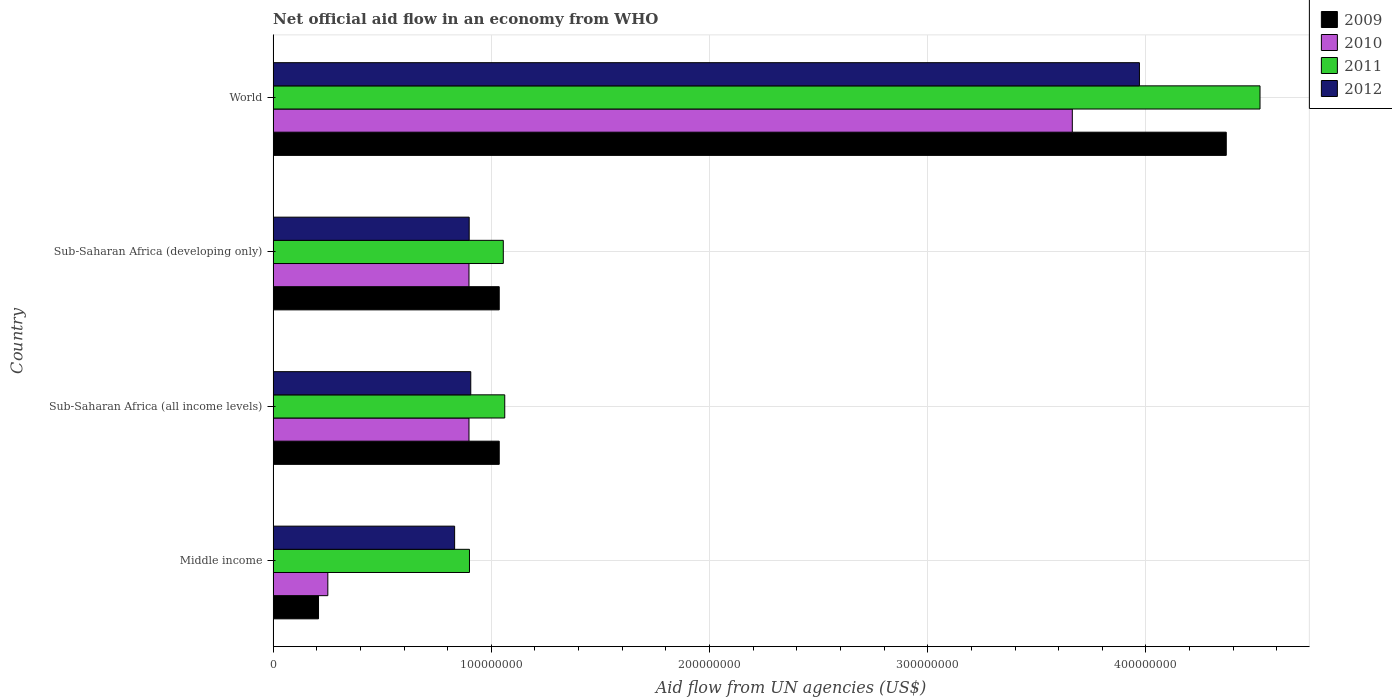How many different coloured bars are there?
Give a very brief answer. 4. Are the number of bars on each tick of the Y-axis equal?
Provide a succinct answer. Yes. How many bars are there on the 1st tick from the top?
Ensure brevity in your answer.  4. What is the label of the 1st group of bars from the top?
Your answer should be compact. World. What is the net official aid flow in 2012 in Sub-Saharan Africa (developing only)?
Keep it short and to the point. 8.98e+07. Across all countries, what is the maximum net official aid flow in 2012?
Offer a terse response. 3.97e+08. Across all countries, what is the minimum net official aid flow in 2011?
Your response must be concise. 9.00e+07. In which country was the net official aid flow in 2011 minimum?
Ensure brevity in your answer.  Middle income. What is the total net official aid flow in 2010 in the graph?
Provide a succinct answer. 5.71e+08. What is the difference between the net official aid flow in 2009 in Sub-Saharan Africa (all income levels) and that in Sub-Saharan Africa (developing only)?
Your answer should be very brief. 0. What is the difference between the net official aid flow in 2011 in Sub-Saharan Africa (all income levels) and the net official aid flow in 2012 in Middle income?
Keep it short and to the point. 2.30e+07. What is the average net official aid flow in 2009 per country?
Your answer should be compact. 1.66e+08. What is the difference between the net official aid flow in 2009 and net official aid flow in 2011 in World?
Your answer should be very brief. -1.55e+07. Is the net official aid flow in 2011 in Middle income less than that in Sub-Saharan Africa (developing only)?
Your answer should be very brief. Yes. Is the difference between the net official aid flow in 2009 in Sub-Saharan Africa (all income levels) and Sub-Saharan Africa (developing only) greater than the difference between the net official aid flow in 2011 in Sub-Saharan Africa (all income levels) and Sub-Saharan Africa (developing only)?
Your response must be concise. No. What is the difference between the highest and the second highest net official aid flow in 2012?
Keep it short and to the point. 3.06e+08. What is the difference between the highest and the lowest net official aid flow in 2011?
Your answer should be compact. 3.62e+08. Is the sum of the net official aid flow in 2009 in Sub-Saharan Africa (developing only) and World greater than the maximum net official aid flow in 2012 across all countries?
Your answer should be very brief. Yes. Is it the case that in every country, the sum of the net official aid flow in 2011 and net official aid flow in 2009 is greater than the sum of net official aid flow in 2012 and net official aid flow in 2010?
Offer a terse response. No. What does the 3rd bar from the top in Middle income represents?
Your answer should be very brief. 2010. Is it the case that in every country, the sum of the net official aid flow in 2010 and net official aid flow in 2009 is greater than the net official aid flow in 2012?
Keep it short and to the point. No. Are all the bars in the graph horizontal?
Offer a very short reply. Yes. How many countries are there in the graph?
Offer a terse response. 4. What is the difference between two consecutive major ticks on the X-axis?
Keep it short and to the point. 1.00e+08. Does the graph contain any zero values?
Keep it short and to the point. No. What is the title of the graph?
Your answer should be very brief. Net official aid flow in an economy from WHO. What is the label or title of the X-axis?
Provide a succinct answer. Aid flow from UN agencies (US$). What is the label or title of the Y-axis?
Offer a terse response. Country. What is the Aid flow from UN agencies (US$) in 2009 in Middle income?
Provide a short and direct response. 2.08e+07. What is the Aid flow from UN agencies (US$) in 2010 in Middle income?
Provide a succinct answer. 2.51e+07. What is the Aid flow from UN agencies (US$) in 2011 in Middle income?
Provide a succinct answer. 9.00e+07. What is the Aid flow from UN agencies (US$) of 2012 in Middle income?
Give a very brief answer. 8.32e+07. What is the Aid flow from UN agencies (US$) of 2009 in Sub-Saharan Africa (all income levels)?
Make the answer very short. 1.04e+08. What is the Aid flow from UN agencies (US$) in 2010 in Sub-Saharan Africa (all income levels)?
Offer a terse response. 8.98e+07. What is the Aid flow from UN agencies (US$) in 2011 in Sub-Saharan Africa (all income levels)?
Ensure brevity in your answer.  1.06e+08. What is the Aid flow from UN agencies (US$) of 2012 in Sub-Saharan Africa (all income levels)?
Ensure brevity in your answer.  9.06e+07. What is the Aid flow from UN agencies (US$) in 2009 in Sub-Saharan Africa (developing only)?
Your answer should be very brief. 1.04e+08. What is the Aid flow from UN agencies (US$) of 2010 in Sub-Saharan Africa (developing only)?
Your answer should be compact. 8.98e+07. What is the Aid flow from UN agencies (US$) in 2011 in Sub-Saharan Africa (developing only)?
Keep it short and to the point. 1.05e+08. What is the Aid flow from UN agencies (US$) in 2012 in Sub-Saharan Africa (developing only)?
Your answer should be compact. 8.98e+07. What is the Aid flow from UN agencies (US$) in 2009 in World?
Your response must be concise. 4.37e+08. What is the Aid flow from UN agencies (US$) of 2010 in World?
Give a very brief answer. 3.66e+08. What is the Aid flow from UN agencies (US$) of 2011 in World?
Offer a very short reply. 4.52e+08. What is the Aid flow from UN agencies (US$) of 2012 in World?
Ensure brevity in your answer.  3.97e+08. Across all countries, what is the maximum Aid flow from UN agencies (US$) of 2009?
Offer a very short reply. 4.37e+08. Across all countries, what is the maximum Aid flow from UN agencies (US$) of 2010?
Ensure brevity in your answer.  3.66e+08. Across all countries, what is the maximum Aid flow from UN agencies (US$) in 2011?
Provide a short and direct response. 4.52e+08. Across all countries, what is the maximum Aid flow from UN agencies (US$) in 2012?
Your answer should be compact. 3.97e+08. Across all countries, what is the minimum Aid flow from UN agencies (US$) in 2009?
Make the answer very short. 2.08e+07. Across all countries, what is the minimum Aid flow from UN agencies (US$) of 2010?
Keep it short and to the point. 2.51e+07. Across all countries, what is the minimum Aid flow from UN agencies (US$) of 2011?
Provide a short and direct response. 9.00e+07. Across all countries, what is the minimum Aid flow from UN agencies (US$) in 2012?
Ensure brevity in your answer.  8.32e+07. What is the total Aid flow from UN agencies (US$) of 2009 in the graph?
Your response must be concise. 6.65e+08. What is the total Aid flow from UN agencies (US$) in 2010 in the graph?
Offer a terse response. 5.71e+08. What is the total Aid flow from UN agencies (US$) in 2011 in the graph?
Provide a succinct answer. 7.54e+08. What is the total Aid flow from UN agencies (US$) of 2012 in the graph?
Offer a very short reply. 6.61e+08. What is the difference between the Aid flow from UN agencies (US$) of 2009 in Middle income and that in Sub-Saharan Africa (all income levels)?
Give a very brief answer. -8.28e+07. What is the difference between the Aid flow from UN agencies (US$) in 2010 in Middle income and that in Sub-Saharan Africa (all income levels)?
Make the answer very short. -6.47e+07. What is the difference between the Aid flow from UN agencies (US$) in 2011 in Middle income and that in Sub-Saharan Africa (all income levels)?
Your response must be concise. -1.62e+07. What is the difference between the Aid flow from UN agencies (US$) of 2012 in Middle income and that in Sub-Saharan Africa (all income levels)?
Offer a terse response. -7.39e+06. What is the difference between the Aid flow from UN agencies (US$) of 2009 in Middle income and that in Sub-Saharan Africa (developing only)?
Your response must be concise. -8.28e+07. What is the difference between the Aid flow from UN agencies (US$) in 2010 in Middle income and that in Sub-Saharan Africa (developing only)?
Give a very brief answer. -6.47e+07. What is the difference between the Aid flow from UN agencies (US$) of 2011 in Middle income and that in Sub-Saharan Africa (developing only)?
Offer a very short reply. -1.55e+07. What is the difference between the Aid flow from UN agencies (US$) of 2012 in Middle income and that in Sub-Saharan Africa (developing only)?
Offer a terse response. -6.67e+06. What is the difference between the Aid flow from UN agencies (US$) of 2009 in Middle income and that in World?
Give a very brief answer. -4.16e+08. What is the difference between the Aid flow from UN agencies (US$) in 2010 in Middle income and that in World?
Keep it short and to the point. -3.41e+08. What is the difference between the Aid flow from UN agencies (US$) in 2011 in Middle income and that in World?
Give a very brief answer. -3.62e+08. What is the difference between the Aid flow from UN agencies (US$) in 2012 in Middle income and that in World?
Offer a terse response. -3.14e+08. What is the difference between the Aid flow from UN agencies (US$) in 2010 in Sub-Saharan Africa (all income levels) and that in Sub-Saharan Africa (developing only)?
Give a very brief answer. 0. What is the difference between the Aid flow from UN agencies (US$) in 2011 in Sub-Saharan Africa (all income levels) and that in Sub-Saharan Africa (developing only)?
Give a very brief answer. 6.70e+05. What is the difference between the Aid flow from UN agencies (US$) of 2012 in Sub-Saharan Africa (all income levels) and that in Sub-Saharan Africa (developing only)?
Offer a terse response. 7.20e+05. What is the difference between the Aid flow from UN agencies (US$) of 2009 in Sub-Saharan Africa (all income levels) and that in World?
Your answer should be compact. -3.33e+08. What is the difference between the Aid flow from UN agencies (US$) of 2010 in Sub-Saharan Africa (all income levels) and that in World?
Give a very brief answer. -2.76e+08. What is the difference between the Aid flow from UN agencies (US$) of 2011 in Sub-Saharan Africa (all income levels) and that in World?
Make the answer very short. -3.46e+08. What is the difference between the Aid flow from UN agencies (US$) of 2012 in Sub-Saharan Africa (all income levels) and that in World?
Make the answer very short. -3.06e+08. What is the difference between the Aid flow from UN agencies (US$) of 2009 in Sub-Saharan Africa (developing only) and that in World?
Offer a terse response. -3.33e+08. What is the difference between the Aid flow from UN agencies (US$) in 2010 in Sub-Saharan Africa (developing only) and that in World?
Provide a short and direct response. -2.76e+08. What is the difference between the Aid flow from UN agencies (US$) in 2011 in Sub-Saharan Africa (developing only) and that in World?
Keep it short and to the point. -3.47e+08. What is the difference between the Aid flow from UN agencies (US$) in 2012 in Sub-Saharan Africa (developing only) and that in World?
Provide a succinct answer. -3.07e+08. What is the difference between the Aid flow from UN agencies (US$) in 2009 in Middle income and the Aid flow from UN agencies (US$) in 2010 in Sub-Saharan Africa (all income levels)?
Provide a short and direct response. -6.90e+07. What is the difference between the Aid flow from UN agencies (US$) of 2009 in Middle income and the Aid flow from UN agencies (US$) of 2011 in Sub-Saharan Africa (all income levels)?
Give a very brief answer. -8.54e+07. What is the difference between the Aid flow from UN agencies (US$) in 2009 in Middle income and the Aid flow from UN agencies (US$) in 2012 in Sub-Saharan Africa (all income levels)?
Provide a succinct answer. -6.98e+07. What is the difference between the Aid flow from UN agencies (US$) in 2010 in Middle income and the Aid flow from UN agencies (US$) in 2011 in Sub-Saharan Africa (all income levels)?
Provide a short and direct response. -8.11e+07. What is the difference between the Aid flow from UN agencies (US$) of 2010 in Middle income and the Aid flow from UN agencies (US$) of 2012 in Sub-Saharan Africa (all income levels)?
Offer a terse response. -6.55e+07. What is the difference between the Aid flow from UN agencies (US$) of 2011 in Middle income and the Aid flow from UN agencies (US$) of 2012 in Sub-Saharan Africa (all income levels)?
Offer a very short reply. -5.90e+05. What is the difference between the Aid flow from UN agencies (US$) of 2009 in Middle income and the Aid flow from UN agencies (US$) of 2010 in Sub-Saharan Africa (developing only)?
Provide a succinct answer. -6.90e+07. What is the difference between the Aid flow from UN agencies (US$) of 2009 in Middle income and the Aid flow from UN agencies (US$) of 2011 in Sub-Saharan Africa (developing only)?
Keep it short and to the point. -8.47e+07. What is the difference between the Aid flow from UN agencies (US$) of 2009 in Middle income and the Aid flow from UN agencies (US$) of 2012 in Sub-Saharan Africa (developing only)?
Your answer should be compact. -6.90e+07. What is the difference between the Aid flow from UN agencies (US$) of 2010 in Middle income and the Aid flow from UN agencies (US$) of 2011 in Sub-Saharan Africa (developing only)?
Ensure brevity in your answer.  -8.04e+07. What is the difference between the Aid flow from UN agencies (US$) of 2010 in Middle income and the Aid flow from UN agencies (US$) of 2012 in Sub-Saharan Africa (developing only)?
Ensure brevity in your answer.  -6.48e+07. What is the difference between the Aid flow from UN agencies (US$) in 2011 in Middle income and the Aid flow from UN agencies (US$) in 2012 in Sub-Saharan Africa (developing only)?
Provide a short and direct response. 1.30e+05. What is the difference between the Aid flow from UN agencies (US$) in 2009 in Middle income and the Aid flow from UN agencies (US$) in 2010 in World?
Provide a short and direct response. -3.45e+08. What is the difference between the Aid flow from UN agencies (US$) in 2009 in Middle income and the Aid flow from UN agencies (US$) in 2011 in World?
Provide a short and direct response. -4.31e+08. What is the difference between the Aid flow from UN agencies (US$) of 2009 in Middle income and the Aid flow from UN agencies (US$) of 2012 in World?
Give a very brief answer. -3.76e+08. What is the difference between the Aid flow from UN agencies (US$) in 2010 in Middle income and the Aid flow from UN agencies (US$) in 2011 in World?
Offer a terse response. -4.27e+08. What is the difference between the Aid flow from UN agencies (US$) of 2010 in Middle income and the Aid flow from UN agencies (US$) of 2012 in World?
Provide a succinct answer. -3.72e+08. What is the difference between the Aid flow from UN agencies (US$) in 2011 in Middle income and the Aid flow from UN agencies (US$) in 2012 in World?
Your answer should be compact. -3.07e+08. What is the difference between the Aid flow from UN agencies (US$) in 2009 in Sub-Saharan Africa (all income levels) and the Aid flow from UN agencies (US$) in 2010 in Sub-Saharan Africa (developing only)?
Offer a terse response. 1.39e+07. What is the difference between the Aid flow from UN agencies (US$) in 2009 in Sub-Saharan Africa (all income levels) and the Aid flow from UN agencies (US$) in 2011 in Sub-Saharan Africa (developing only)?
Your answer should be very brief. -1.86e+06. What is the difference between the Aid flow from UN agencies (US$) in 2009 in Sub-Saharan Africa (all income levels) and the Aid flow from UN agencies (US$) in 2012 in Sub-Saharan Africa (developing only)?
Offer a terse response. 1.38e+07. What is the difference between the Aid flow from UN agencies (US$) in 2010 in Sub-Saharan Africa (all income levels) and the Aid flow from UN agencies (US$) in 2011 in Sub-Saharan Africa (developing only)?
Your answer should be compact. -1.57e+07. What is the difference between the Aid flow from UN agencies (US$) of 2011 in Sub-Saharan Africa (all income levels) and the Aid flow from UN agencies (US$) of 2012 in Sub-Saharan Africa (developing only)?
Ensure brevity in your answer.  1.63e+07. What is the difference between the Aid flow from UN agencies (US$) of 2009 in Sub-Saharan Africa (all income levels) and the Aid flow from UN agencies (US$) of 2010 in World?
Your answer should be compact. -2.63e+08. What is the difference between the Aid flow from UN agencies (US$) of 2009 in Sub-Saharan Africa (all income levels) and the Aid flow from UN agencies (US$) of 2011 in World?
Keep it short and to the point. -3.49e+08. What is the difference between the Aid flow from UN agencies (US$) in 2009 in Sub-Saharan Africa (all income levels) and the Aid flow from UN agencies (US$) in 2012 in World?
Offer a terse response. -2.93e+08. What is the difference between the Aid flow from UN agencies (US$) of 2010 in Sub-Saharan Africa (all income levels) and the Aid flow from UN agencies (US$) of 2011 in World?
Your answer should be compact. -3.62e+08. What is the difference between the Aid flow from UN agencies (US$) in 2010 in Sub-Saharan Africa (all income levels) and the Aid flow from UN agencies (US$) in 2012 in World?
Offer a very short reply. -3.07e+08. What is the difference between the Aid flow from UN agencies (US$) in 2011 in Sub-Saharan Africa (all income levels) and the Aid flow from UN agencies (US$) in 2012 in World?
Make the answer very short. -2.91e+08. What is the difference between the Aid flow from UN agencies (US$) in 2009 in Sub-Saharan Africa (developing only) and the Aid flow from UN agencies (US$) in 2010 in World?
Your response must be concise. -2.63e+08. What is the difference between the Aid flow from UN agencies (US$) of 2009 in Sub-Saharan Africa (developing only) and the Aid flow from UN agencies (US$) of 2011 in World?
Your answer should be very brief. -3.49e+08. What is the difference between the Aid flow from UN agencies (US$) of 2009 in Sub-Saharan Africa (developing only) and the Aid flow from UN agencies (US$) of 2012 in World?
Give a very brief answer. -2.93e+08. What is the difference between the Aid flow from UN agencies (US$) in 2010 in Sub-Saharan Africa (developing only) and the Aid flow from UN agencies (US$) in 2011 in World?
Your answer should be very brief. -3.62e+08. What is the difference between the Aid flow from UN agencies (US$) in 2010 in Sub-Saharan Africa (developing only) and the Aid flow from UN agencies (US$) in 2012 in World?
Ensure brevity in your answer.  -3.07e+08. What is the difference between the Aid flow from UN agencies (US$) in 2011 in Sub-Saharan Africa (developing only) and the Aid flow from UN agencies (US$) in 2012 in World?
Provide a short and direct response. -2.92e+08. What is the average Aid flow from UN agencies (US$) in 2009 per country?
Offer a very short reply. 1.66e+08. What is the average Aid flow from UN agencies (US$) in 2010 per country?
Ensure brevity in your answer.  1.43e+08. What is the average Aid flow from UN agencies (US$) in 2011 per country?
Offer a terse response. 1.88e+08. What is the average Aid flow from UN agencies (US$) in 2012 per country?
Keep it short and to the point. 1.65e+08. What is the difference between the Aid flow from UN agencies (US$) of 2009 and Aid flow from UN agencies (US$) of 2010 in Middle income?
Keep it short and to the point. -4.27e+06. What is the difference between the Aid flow from UN agencies (US$) of 2009 and Aid flow from UN agencies (US$) of 2011 in Middle income?
Offer a very short reply. -6.92e+07. What is the difference between the Aid flow from UN agencies (US$) of 2009 and Aid flow from UN agencies (US$) of 2012 in Middle income?
Your response must be concise. -6.24e+07. What is the difference between the Aid flow from UN agencies (US$) of 2010 and Aid flow from UN agencies (US$) of 2011 in Middle income?
Offer a very short reply. -6.49e+07. What is the difference between the Aid flow from UN agencies (US$) of 2010 and Aid flow from UN agencies (US$) of 2012 in Middle income?
Ensure brevity in your answer.  -5.81e+07. What is the difference between the Aid flow from UN agencies (US$) in 2011 and Aid flow from UN agencies (US$) in 2012 in Middle income?
Your response must be concise. 6.80e+06. What is the difference between the Aid flow from UN agencies (US$) of 2009 and Aid flow from UN agencies (US$) of 2010 in Sub-Saharan Africa (all income levels)?
Provide a short and direct response. 1.39e+07. What is the difference between the Aid flow from UN agencies (US$) in 2009 and Aid flow from UN agencies (US$) in 2011 in Sub-Saharan Africa (all income levels)?
Provide a succinct answer. -2.53e+06. What is the difference between the Aid flow from UN agencies (US$) of 2009 and Aid flow from UN agencies (US$) of 2012 in Sub-Saharan Africa (all income levels)?
Ensure brevity in your answer.  1.30e+07. What is the difference between the Aid flow from UN agencies (US$) in 2010 and Aid flow from UN agencies (US$) in 2011 in Sub-Saharan Africa (all income levels)?
Ensure brevity in your answer.  -1.64e+07. What is the difference between the Aid flow from UN agencies (US$) of 2010 and Aid flow from UN agencies (US$) of 2012 in Sub-Saharan Africa (all income levels)?
Provide a succinct answer. -8.10e+05. What is the difference between the Aid flow from UN agencies (US$) in 2011 and Aid flow from UN agencies (US$) in 2012 in Sub-Saharan Africa (all income levels)?
Provide a short and direct response. 1.56e+07. What is the difference between the Aid flow from UN agencies (US$) in 2009 and Aid flow from UN agencies (US$) in 2010 in Sub-Saharan Africa (developing only)?
Give a very brief answer. 1.39e+07. What is the difference between the Aid flow from UN agencies (US$) of 2009 and Aid flow from UN agencies (US$) of 2011 in Sub-Saharan Africa (developing only)?
Provide a succinct answer. -1.86e+06. What is the difference between the Aid flow from UN agencies (US$) in 2009 and Aid flow from UN agencies (US$) in 2012 in Sub-Saharan Africa (developing only)?
Ensure brevity in your answer.  1.38e+07. What is the difference between the Aid flow from UN agencies (US$) in 2010 and Aid flow from UN agencies (US$) in 2011 in Sub-Saharan Africa (developing only)?
Your answer should be compact. -1.57e+07. What is the difference between the Aid flow from UN agencies (US$) in 2010 and Aid flow from UN agencies (US$) in 2012 in Sub-Saharan Africa (developing only)?
Make the answer very short. -9.00e+04. What is the difference between the Aid flow from UN agencies (US$) in 2011 and Aid flow from UN agencies (US$) in 2012 in Sub-Saharan Africa (developing only)?
Offer a very short reply. 1.56e+07. What is the difference between the Aid flow from UN agencies (US$) of 2009 and Aid flow from UN agencies (US$) of 2010 in World?
Provide a short and direct response. 7.06e+07. What is the difference between the Aid flow from UN agencies (US$) in 2009 and Aid flow from UN agencies (US$) in 2011 in World?
Your response must be concise. -1.55e+07. What is the difference between the Aid flow from UN agencies (US$) in 2009 and Aid flow from UN agencies (US$) in 2012 in World?
Provide a short and direct response. 3.98e+07. What is the difference between the Aid flow from UN agencies (US$) in 2010 and Aid flow from UN agencies (US$) in 2011 in World?
Keep it short and to the point. -8.60e+07. What is the difference between the Aid flow from UN agencies (US$) in 2010 and Aid flow from UN agencies (US$) in 2012 in World?
Ensure brevity in your answer.  -3.08e+07. What is the difference between the Aid flow from UN agencies (US$) of 2011 and Aid flow from UN agencies (US$) of 2012 in World?
Offer a terse response. 5.53e+07. What is the ratio of the Aid flow from UN agencies (US$) of 2009 in Middle income to that in Sub-Saharan Africa (all income levels)?
Your answer should be very brief. 0.2. What is the ratio of the Aid flow from UN agencies (US$) of 2010 in Middle income to that in Sub-Saharan Africa (all income levels)?
Provide a succinct answer. 0.28. What is the ratio of the Aid flow from UN agencies (US$) in 2011 in Middle income to that in Sub-Saharan Africa (all income levels)?
Offer a very short reply. 0.85. What is the ratio of the Aid flow from UN agencies (US$) in 2012 in Middle income to that in Sub-Saharan Africa (all income levels)?
Keep it short and to the point. 0.92. What is the ratio of the Aid flow from UN agencies (US$) in 2009 in Middle income to that in Sub-Saharan Africa (developing only)?
Your answer should be very brief. 0.2. What is the ratio of the Aid flow from UN agencies (US$) in 2010 in Middle income to that in Sub-Saharan Africa (developing only)?
Ensure brevity in your answer.  0.28. What is the ratio of the Aid flow from UN agencies (US$) in 2011 in Middle income to that in Sub-Saharan Africa (developing only)?
Your response must be concise. 0.85. What is the ratio of the Aid flow from UN agencies (US$) in 2012 in Middle income to that in Sub-Saharan Africa (developing only)?
Provide a short and direct response. 0.93. What is the ratio of the Aid flow from UN agencies (US$) of 2009 in Middle income to that in World?
Offer a very short reply. 0.05. What is the ratio of the Aid flow from UN agencies (US$) in 2010 in Middle income to that in World?
Offer a terse response. 0.07. What is the ratio of the Aid flow from UN agencies (US$) of 2011 in Middle income to that in World?
Your answer should be very brief. 0.2. What is the ratio of the Aid flow from UN agencies (US$) of 2012 in Middle income to that in World?
Offer a very short reply. 0.21. What is the ratio of the Aid flow from UN agencies (US$) in 2010 in Sub-Saharan Africa (all income levels) to that in Sub-Saharan Africa (developing only)?
Give a very brief answer. 1. What is the ratio of the Aid flow from UN agencies (US$) in 2011 in Sub-Saharan Africa (all income levels) to that in Sub-Saharan Africa (developing only)?
Keep it short and to the point. 1.01. What is the ratio of the Aid flow from UN agencies (US$) in 2012 in Sub-Saharan Africa (all income levels) to that in Sub-Saharan Africa (developing only)?
Your response must be concise. 1.01. What is the ratio of the Aid flow from UN agencies (US$) of 2009 in Sub-Saharan Africa (all income levels) to that in World?
Give a very brief answer. 0.24. What is the ratio of the Aid flow from UN agencies (US$) in 2010 in Sub-Saharan Africa (all income levels) to that in World?
Your response must be concise. 0.25. What is the ratio of the Aid flow from UN agencies (US$) in 2011 in Sub-Saharan Africa (all income levels) to that in World?
Your response must be concise. 0.23. What is the ratio of the Aid flow from UN agencies (US$) of 2012 in Sub-Saharan Africa (all income levels) to that in World?
Your answer should be very brief. 0.23. What is the ratio of the Aid flow from UN agencies (US$) of 2009 in Sub-Saharan Africa (developing only) to that in World?
Your answer should be very brief. 0.24. What is the ratio of the Aid flow from UN agencies (US$) of 2010 in Sub-Saharan Africa (developing only) to that in World?
Make the answer very short. 0.25. What is the ratio of the Aid flow from UN agencies (US$) in 2011 in Sub-Saharan Africa (developing only) to that in World?
Ensure brevity in your answer.  0.23. What is the ratio of the Aid flow from UN agencies (US$) of 2012 in Sub-Saharan Africa (developing only) to that in World?
Ensure brevity in your answer.  0.23. What is the difference between the highest and the second highest Aid flow from UN agencies (US$) of 2009?
Keep it short and to the point. 3.33e+08. What is the difference between the highest and the second highest Aid flow from UN agencies (US$) in 2010?
Keep it short and to the point. 2.76e+08. What is the difference between the highest and the second highest Aid flow from UN agencies (US$) of 2011?
Give a very brief answer. 3.46e+08. What is the difference between the highest and the second highest Aid flow from UN agencies (US$) in 2012?
Offer a terse response. 3.06e+08. What is the difference between the highest and the lowest Aid flow from UN agencies (US$) in 2009?
Offer a very short reply. 4.16e+08. What is the difference between the highest and the lowest Aid flow from UN agencies (US$) of 2010?
Your answer should be compact. 3.41e+08. What is the difference between the highest and the lowest Aid flow from UN agencies (US$) in 2011?
Offer a very short reply. 3.62e+08. What is the difference between the highest and the lowest Aid flow from UN agencies (US$) of 2012?
Give a very brief answer. 3.14e+08. 